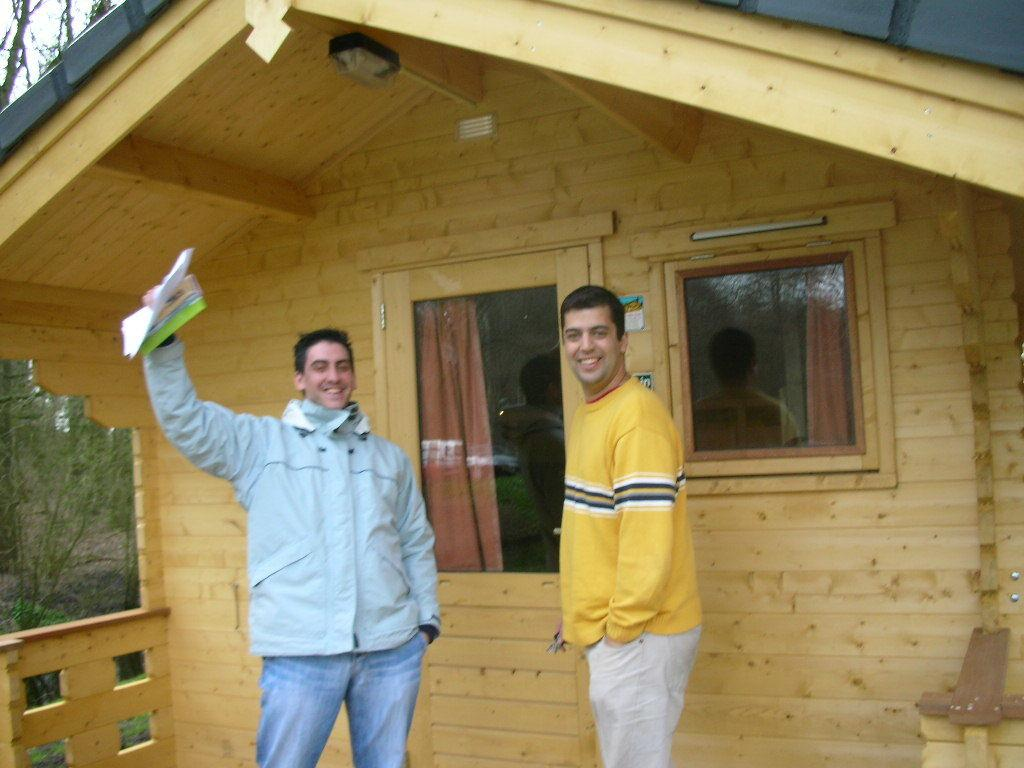How many people are present in the image? There are two persons standing in the image. What is one of the persons holding? One of the persons is holding papers. What can be seen in the background of the image? There is a house and trees in the background of the image. What is the aftermath of the plot in the image? There is no plot or storyline depicted in the image, so it's not possible to determine the aftermath. 